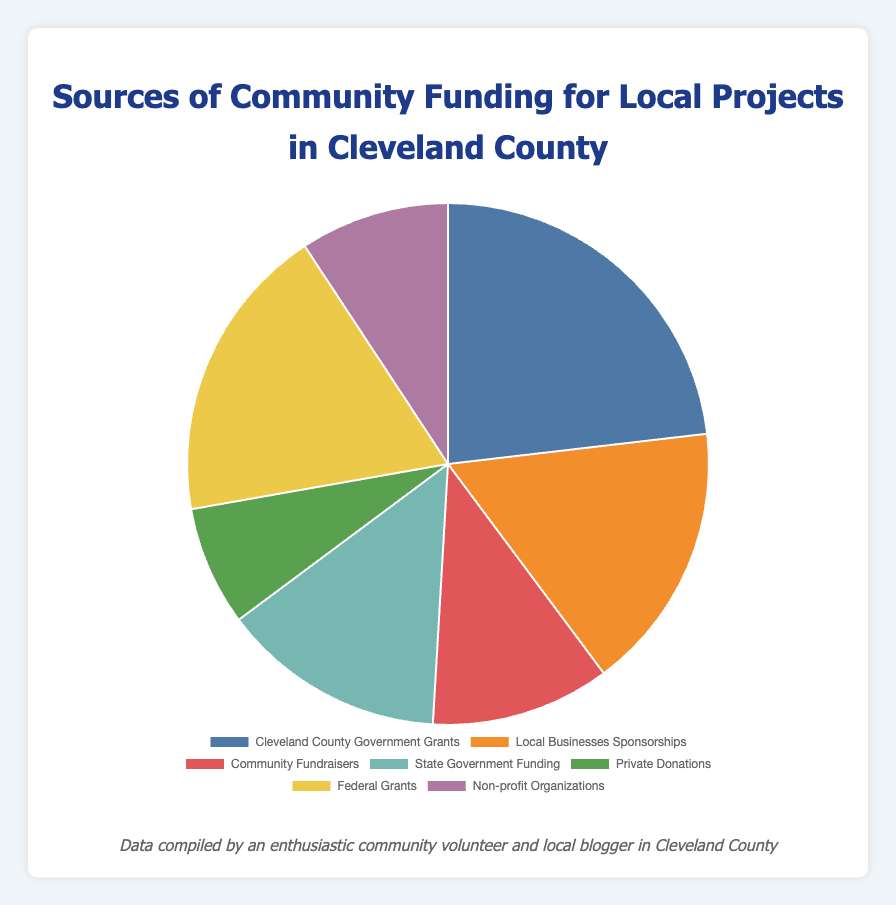Which source provides the highest amount of funding? The source with the largest slice of the pie chart is "Cleveland County Government Grants" with an amount of $25,000.
Answer: Cleveland County Government Grants Which source provides the lowest amount of funding? The source with the smallest slice of the pie chart is "Private Donations" with an amount of $8,000.
Answer: Private Donations What is the total amount of funding from non-government sources? Non-government sources include Local Businesses Sponsorships ($18,000), Community Fundraisers ($12,000), Private Donations ($8,000), and Non-profit Organizations ($10,000). Summing these gives: 18000 + 12000 + 8000 + 10000 = $48,000.
Answer: $48,000 How much more funding does "Federal Grants" provide compared to "Local Businesses Sponsorships"? Federal Grants provide $20,000 and Local Businesses Sponsorships provide $18,000. The difference is 20000 - 18000 = $2,000.
Answer: $2,000 What is the combined funding amount of "Cleveland County Government Grants" and "State Government Funding"? Cleveland County Government Grants provide $25,000 and State Government Funding provides $15,000. Combined, this is 25000 + 15000 = $40,000.
Answer: $40,000 Is the funding from "Community Fundraisers" greater than "Non-profit Organizations"? Community Fundraisers provide $12,000 and Non-profit Organizations provide $10,000. Since 12000 > 10000, the answer is yes.
Answer: Yes Which source is represented by the green section of the pie chart? The pie chart shows that the green section corresponds to "Private Donations."
Answer: Private Donations What percentage of the total funding comes from "Federal Grants"? The total funding is 25000 + 18000 + 12000 + 15000 + 8000 + 20000 + 10000 = $108,000. The percentage from Federal Grants is (20000 / 108000) * 100 ≈ 18.5%.
Answer: 18.5% What is the median amount of the funding sources listed? Listing the amounts in ascending order: $8,000, $10,000, $12,000, $15,000, $18,000, $20,000, $25,000. The median value is the middle value, which is $15,000.
Answer: $15,000 